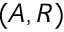<formula> <loc_0><loc_0><loc_500><loc_500>( A , R )</formula> 